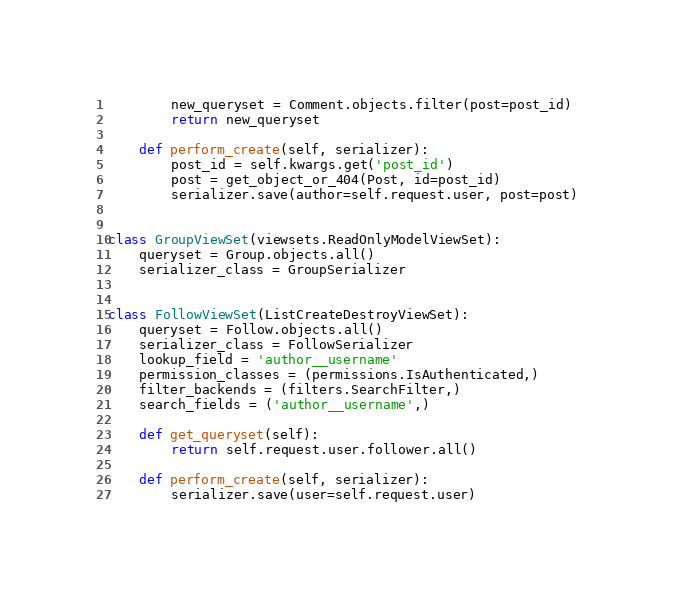Convert code to text. <code><loc_0><loc_0><loc_500><loc_500><_Python_>        new_queryset = Comment.objects.filter(post=post_id)
        return new_queryset

    def perform_create(self, serializer):
        post_id = self.kwargs.get('post_id')
        post = get_object_or_404(Post, id=post_id)
        serializer.save(author=self.request.user, post=post)


class GroupViewSet(viewsets.ReadOnlyModelViewSet):
    queryset = Group.objects.all()
    serializer_class = GroupSerializer


class FollowViewSet(ListCreateDestroyViewSet):
    queryset = Follow.objects.all()
    serializer_class = FollowSerializer
    lookup_field = 'author__username'
    permission_classes = (permissions.IsAuthenticated,)
    filter_backends = (filters.SearchFilter,)
    search_fields = ('author__username',)

    def get_queryset(self):
        return self.request.user.follower.all()

    def perform_create(self, serializer):
        serializer.save(user=self.request.user)
</code> 